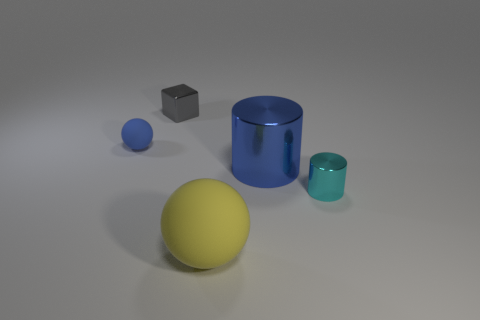There is a blue thing that is the same material as the large yellow ball; what is its shape?
Make the answer very short. Sphere. There is a yellow thing in front of the large cylinder; is its shape the same as the cyan thing?
Your answer should be compact. No. The tiny metallic thing to the left of the yellow ball has what shape?
Make the answer very short. Cube. There is a object that is the same color as the large metallic cylinder; what shape is it?
Ensure brevity in your answer.  Sphere. What number of red metallic balls are the same size as the blue matte sphere?
Your answer should be compact. 0. What color is the tiny metal cylinder?
Give a very brief answer. Cyan. There is a large matte thing; does it have the same color as the matte ball that is behind the large shiny object?
Your answer should be compact. No. What size is the cyan cylinder that is made of the same material as the gray thing?
Your response must be concise. Small. Is there another small block that has the same color as the small cube?
Make the answer very short. No. How many things are either cylinders that are to the left of the tiny cyan cylinder or big gray cylinders?
Your answer should be very brief. 1. 